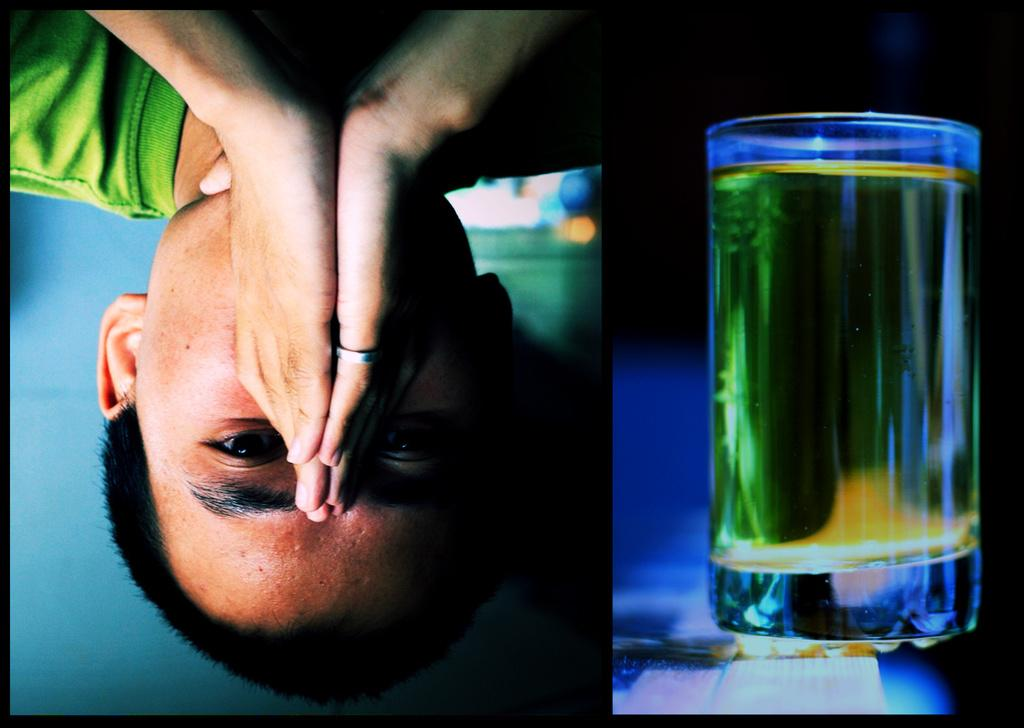What is the main subject of the image? There is a person in the image. Can you describe any objects near the person? There is a glass on the right side of the image. How many nails are holding the vase in the image? There is no vase or nails present in the image. 